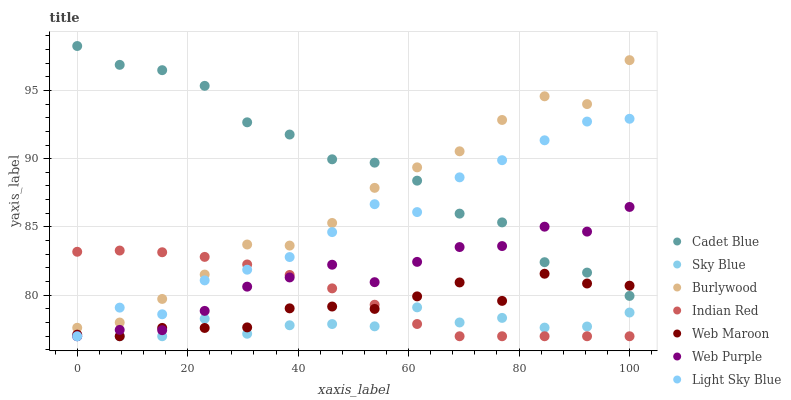Does Sky Blue have the minimum area under the curve?
Answer yes or no. Yes. Does Cadet Blue have the maximum area under the curve?
Answer yes or no. Yes. Does Burlywood have the minimum area under the curve?
Answer yes or no. No. Does Burlywood have the maximum area under the curve?
Answer yes or no. No. Is Indian Red the smoothest?
Answer yes or no. Yes. Is Light Sky Blue the roughest?
Answer yes or no. Yes. Is Burlywood the smoothest?
Answer yes or no. No. Is Burlywood the roughest?
Answer yes or no. No. Does Web Maroon have the lowest value?
Answer yes or no. Yes. Does Burlywood have the lowest value?
Answer yes or no. No. Does Cadet Blue have the highest value?
Answer yes or no. Yes. Does Burlywood have the highest value?
Answer yes or no. No. Is Indian Red less than Cadet Blue?
Answer yes or no. Yes. Is Burlywood greater than Sky Blue?
Answer yes or no. Yes. Does Indian Red intersect Sky Blue?
Answer yes or no. Yes. Is Indian Red less than Sky Blue?
Answer yes or no. No. Is Indian Red greater than Sky Blue?
Answer yes or no. No. Does Indian Red intersect Cadet Blue?
Answer yes or no. No. 